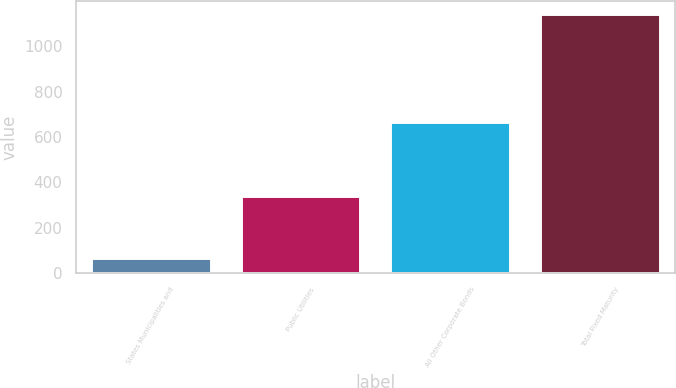Convert chart. <chart><loc_0><loc_0><loc_500><loc_500><bar_chart><fcel>States Municipalities and<fcel>Public Utilities<fcel>All Other Corporate Bonds<fcel>Total Fixed Maturity<nl><fcel>68.1<fcel>338.9<fcel>665.5<fcel>1141.4<nl></chart> 